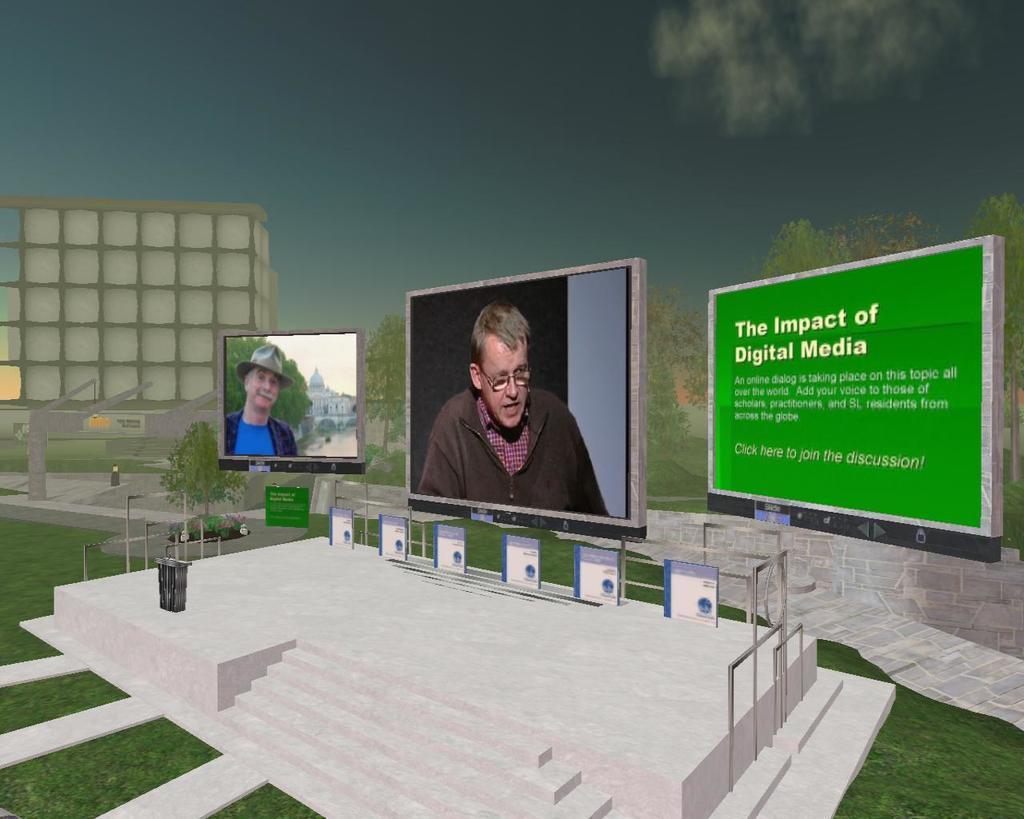Please provide a concise description of this image. This is an edited image. In the background there are three screens. There are two photographs of two persons. On this screen there are some texts. This is the stage. In the background there are trees. The sky is cloudy. 